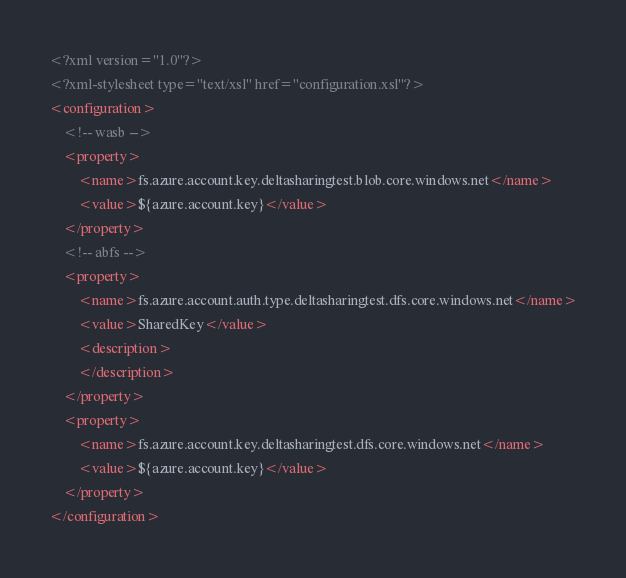<code> <loc_0><loc_0><loc_500><loc_500><_XML_><?xml version="1.0"?>
<?xml-stylesheet type="text/xsl" href="configuration.xsl"?>
<configuration>
    <!-- wasb -->
    <property>
        <name>fs.azure.account.key.deltasharingtest.blob.core.windows.net</name>
        <value>${azure.account.key}</value>
    </property>
    <!-- abfs -->
    <property>
        <name>fs.azure.account.auth.type.deltasharingtest.dfs.core.windows.net</name>
        <value>SharedKey</value>
        <description>
        </description>
    </property>
    <property>
        <name>fs.azure.account.key.deltasharingtest.dfs.core.windows.net</name>
        <value>${azure.account.key}</value>
    </property>
</configuration>
</code> 